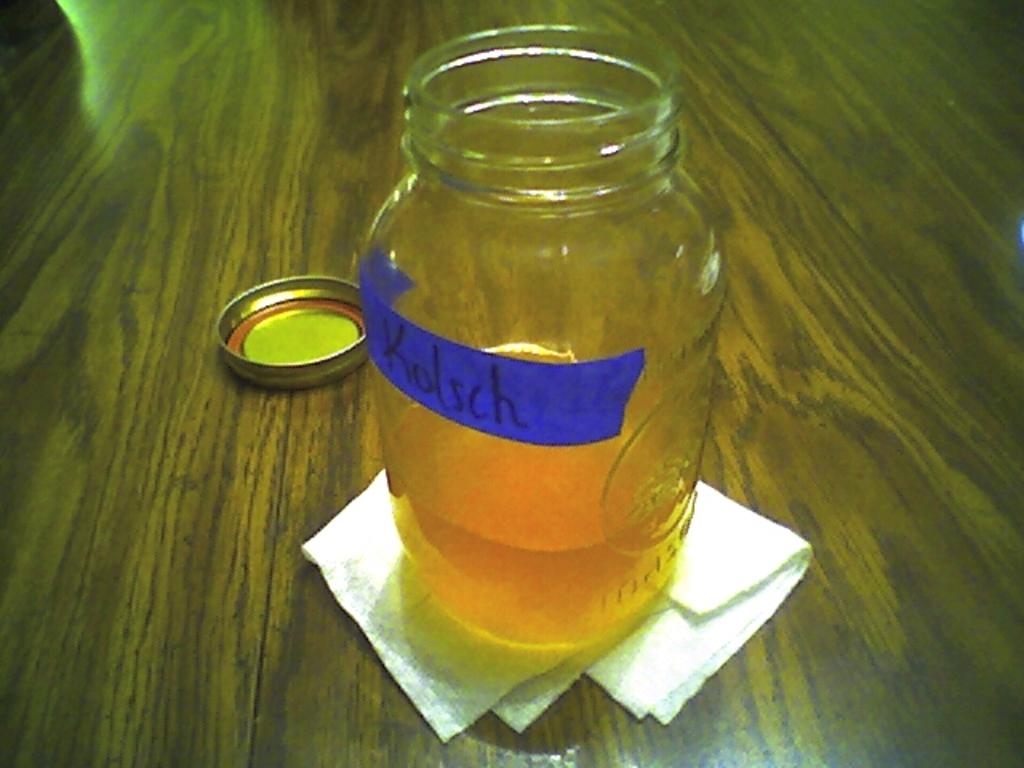<image>
Summarize the visual content of the image. A open mason jar with Kolsch written on blue tape stuck to the jar. 